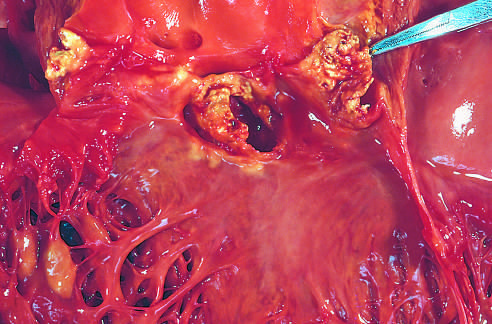s acute endocarditis caused by staphylococcus aureus on a congenitally bicuspid aortic valve with extensive cuspal destruction and ring abscess?
Answer the question using a single word or phrase. Yes 